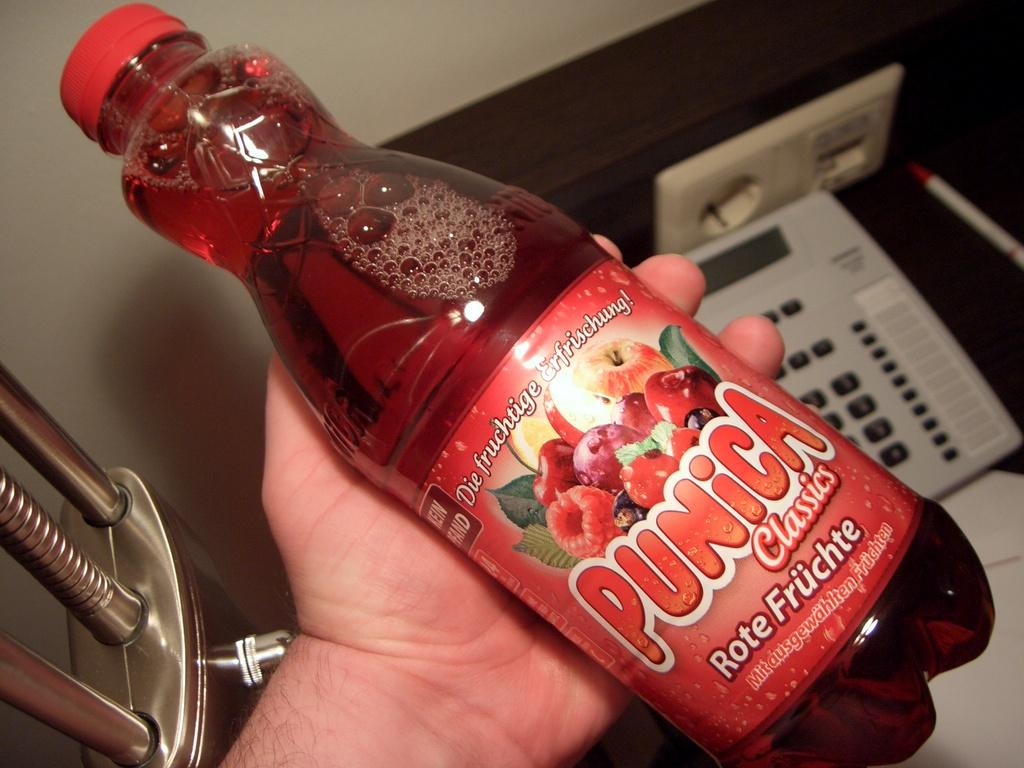<image>
Provide a brief description of the given image. Someone is holding a full bottle of red Punica with different red fruits on the label. 